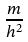<formula> <loc_0><loc_0><loc_500><loc_500>\frac { m } { h ^ { 2 } }</formula> 